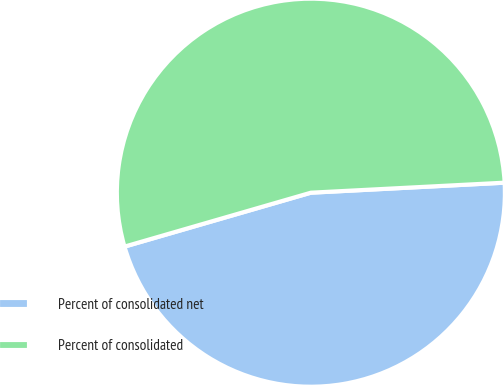Convert chart to OTSL. <chart><loc_0><loc_0><loc_500><loc_500><pie_chart><fcel>Percent of consolidated net<fcel>Percent of consolidated<nl><fcel>46.34%<fcel>53.66%<nl></chart> 